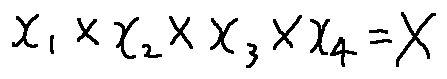<formula> <loc_0><loc_0><loc_500><loc_500>x _ { 1 } \times x _ { 2 } \times x _ { 3 } \times x _ { 4 } = X</formula> 